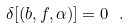Convert formula to latex. <formula><loc_0><loc_0><loc_500><loc_500>\delta [ ( b , f , \alpha ) ] = 0 \ .</formula> 